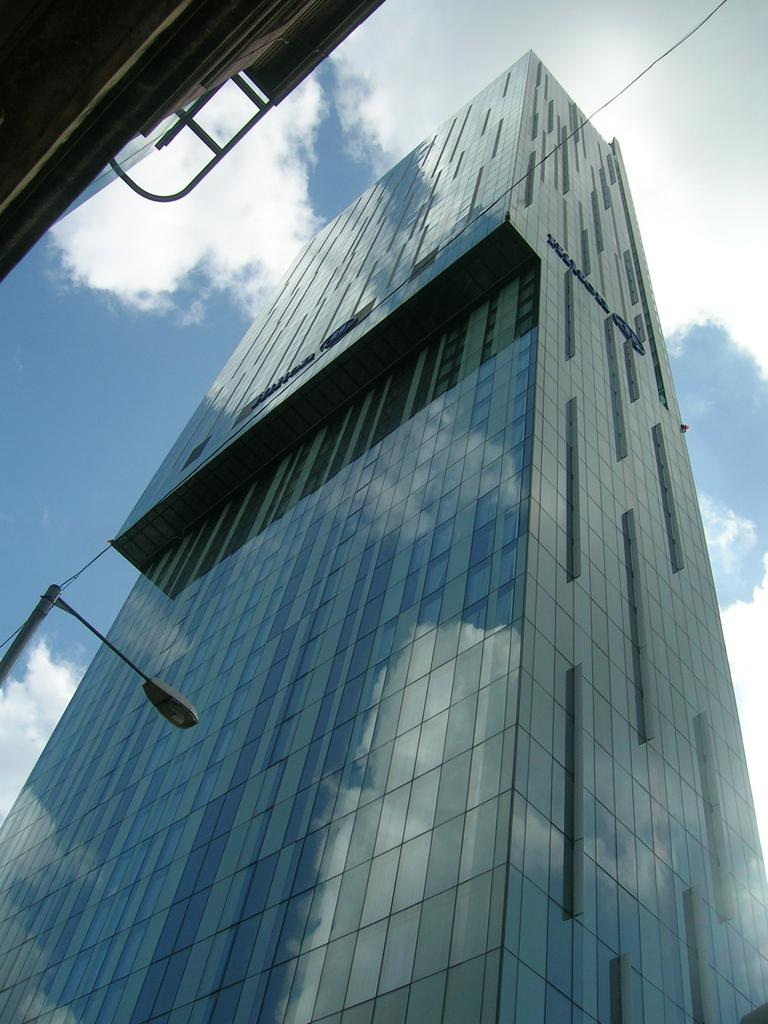What type of structures can be seen in the image? There are buildings in the image. What else can be seen in the image besides the buildings? There are poles visible in the image. What is visible in the background of the image? Clouds and the sky are visible in the background of the image. What type of nation is depicted in the image? There is no specific nation depicted in the image; it simply shows buildings, poles, clouds, and the sky. Where can the ice be found in the image? There is no ice present in the image. 